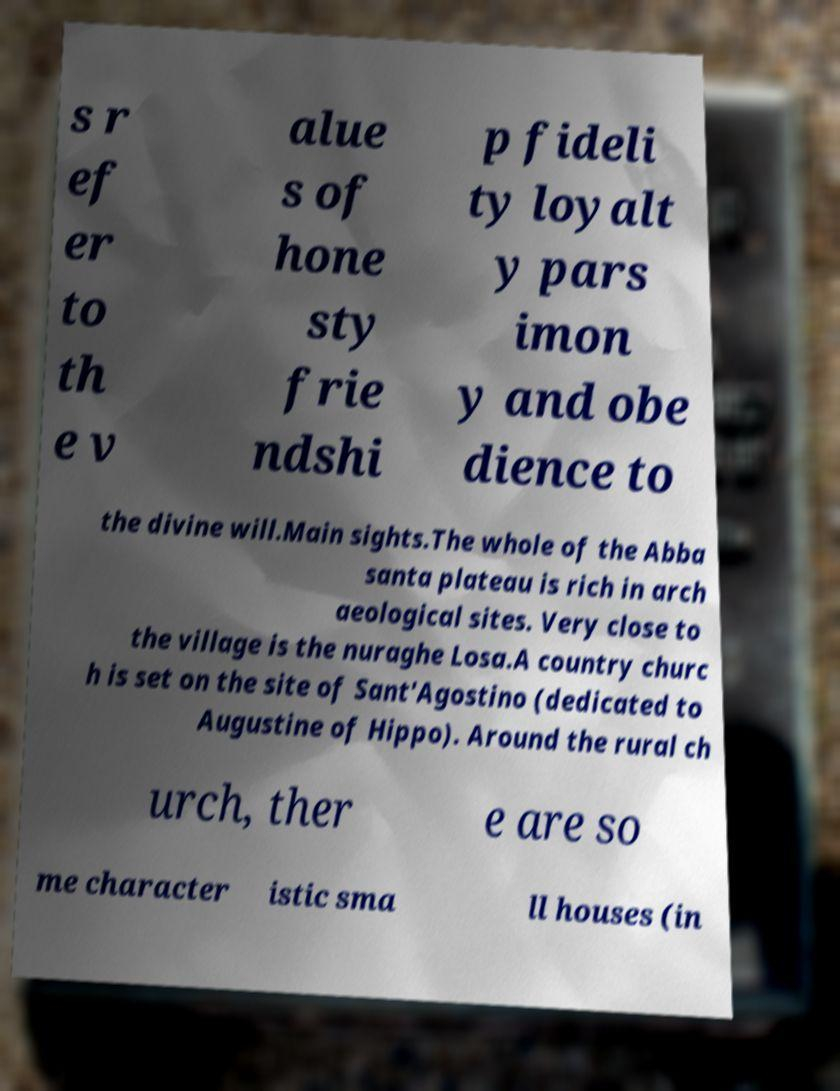Could you extract and type out the text from this image? s r ef er to th e v alue s of hone sty frie ndshi p fideli ty loyalt y pars imon y and obe dience to the divine will.Main sights.The whole of the Abba santa plateau is rich in arch aeological sites. Very close to the village is the nuraghe Losa.A country churc h is set on the site of Sant'Agostino (dedicated to Augustine of Hippo). Around the rural ch urch, ther e are so me character istic sma ll houses (in 